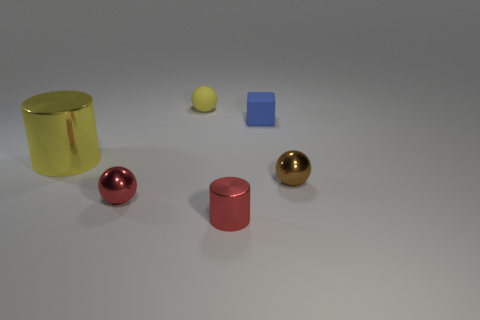Add 2 small red shiny balls. How many objects exist? 8 Subtract all cubes. How many objects are left? 5 Subtract 0 yellow cubes. How many objects are left? 6 Subtract all large green metallic cylinders. Subtract all yellow objects. How many objects are left? 4 Add 4 tiny spheres. How many tiny spheres are left? 7 Add 3 tiny brown matte objects. How many tiny brown matte objects exist? 3 